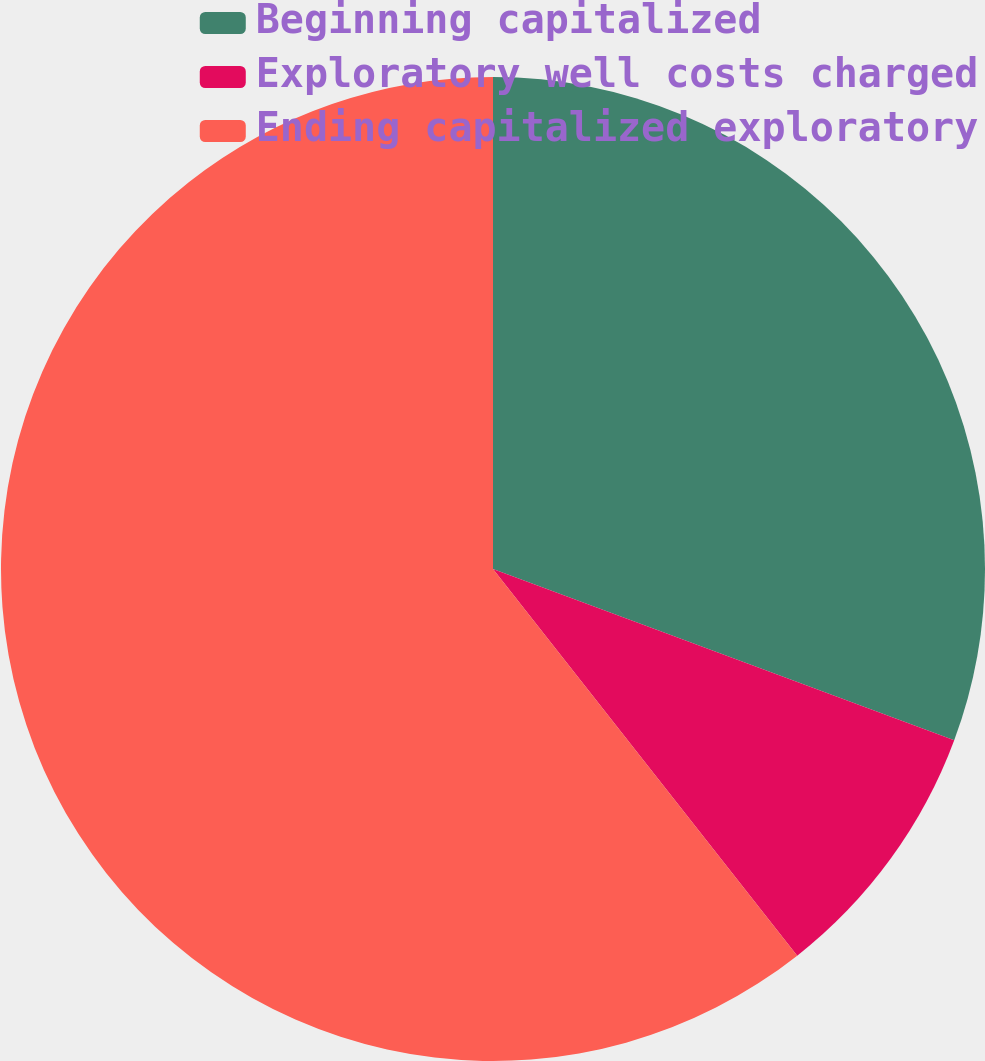<chart> <loc_0><loc_0><loc_500><loc_500><pie_chart><fcel>Beginning capitalized<fcel>Exploratory well costs charged<fcel>Ending capitalized exploratory<nl><fcel>30.66%<fcel>8.73%<fcel>60.61%<nl></chart> 